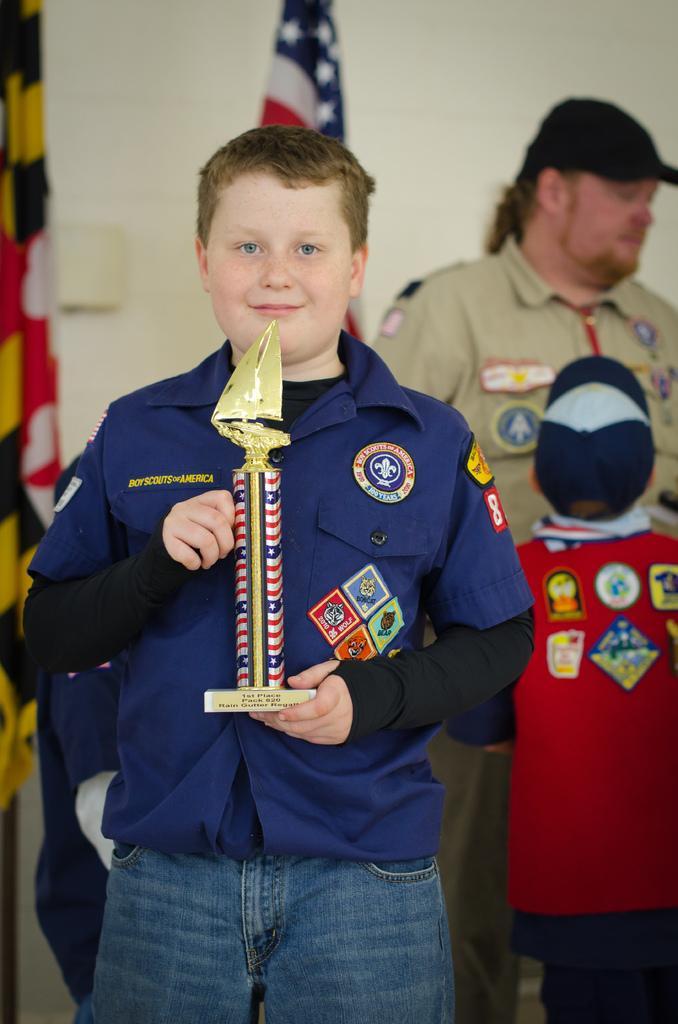Describe this image in one or two sentences. In this image we can see a boy holding a memento in his hands. On the top of the image we can see the flag. On the right side of the image we can see two people are standing. 